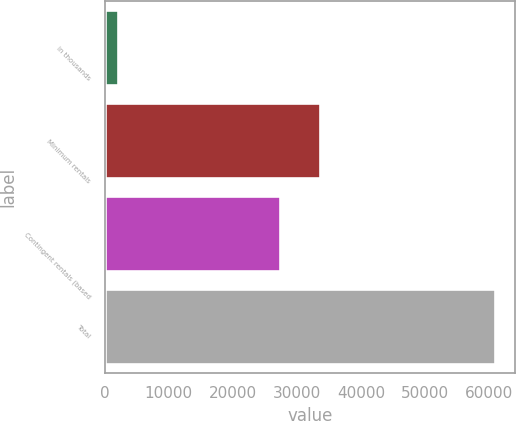<chart> <loc_0><loc_0><loc_500><loc_500><bar_chart><fcel>in thousands<fcel>Minimum rentals<fcel>Contingent rentals (based<fcel>Total<nl><fcel>2010<fcel>33573<fcel>27418<fcel>60991<nl></chart> 